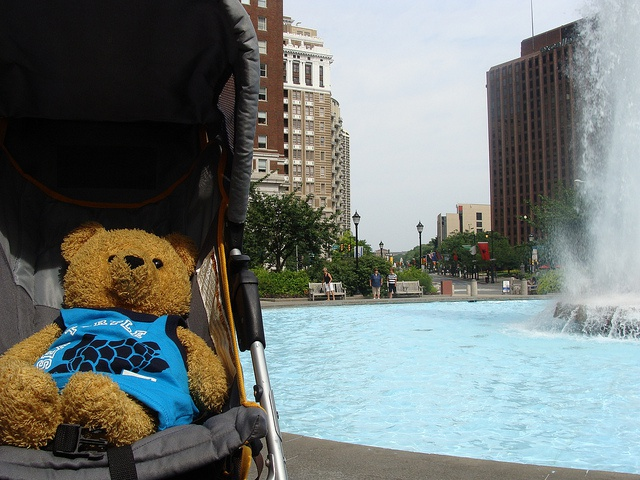Describe the objects in this image and their specific colors. I can see teddy bear in black, olive, teal, and maroon tones, people in black, darkgray, gray, and tan tones, people in black, gray, and navy tones, people in black, gray, and darkgray tones, and people in black, gray, and darkgreen tones in this image. 